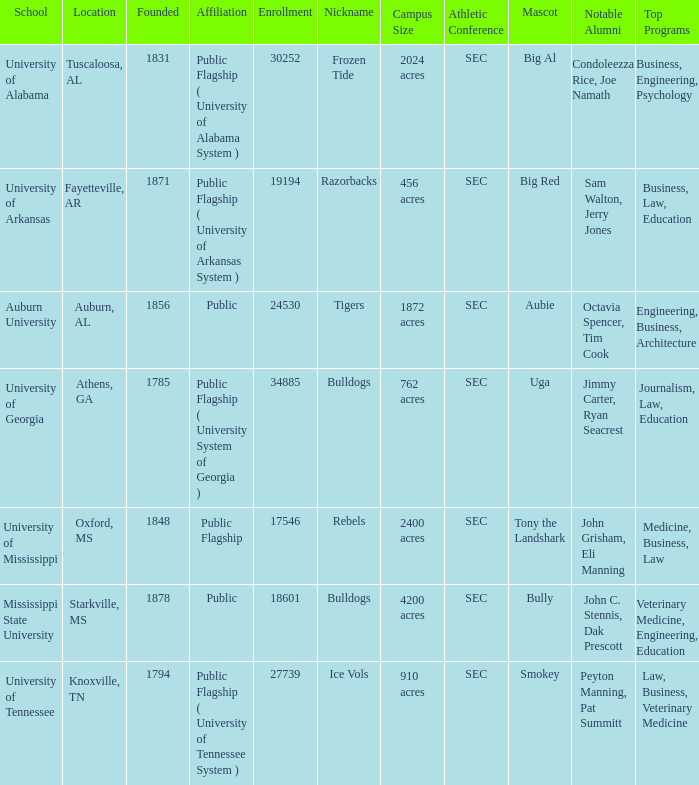What is the maximum enrollment of the schools? 34885.0. 